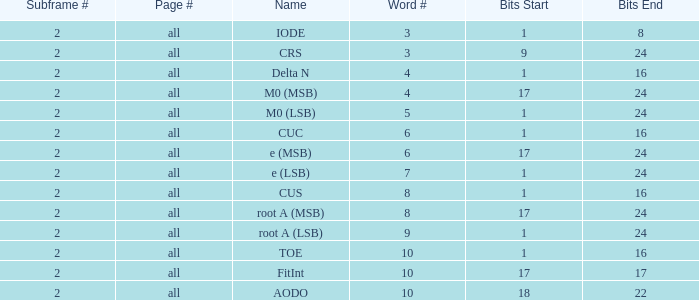What is the total subframe count with Bits of 18–22? 2.0. 